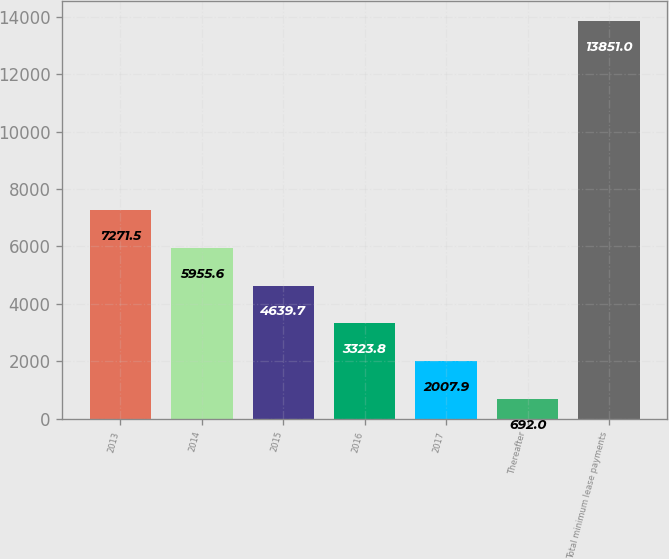Convert chart. <chart><loc_0><loc_0><loc_500><loc_500><bar_chart><fcel>2013<fcel>2014<fcel>2015<fcel>2016<fcel>2017<fcel>Thereafter<fcel>Total minimum lease payments<nl><fcel>7271.5<fcel>5955.6<fcel>4639.7<fcel>3323.8<fcel>2007.9<fcel>692<fcel>13851<nl></chart> 